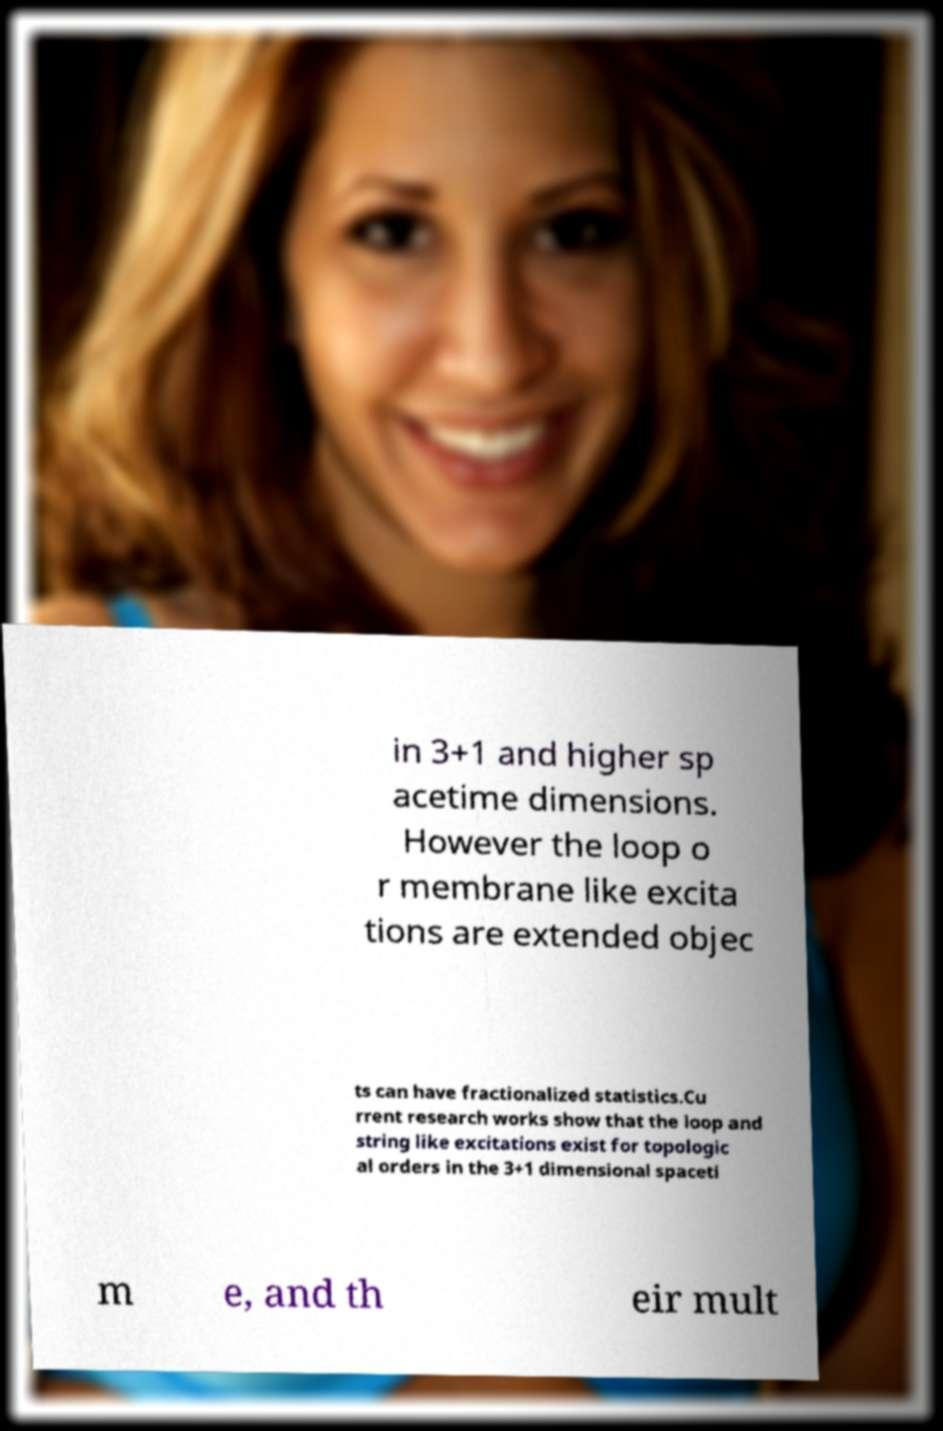Could you extract and type out the text from this image? in 3+1 and higher sp acetime dimensions. However the loop o r membrane like excita tions are extended objec ts can have fractionalized statistics.Cu rrent research works show that the loop and string like excitations exist for topologic al orders in the 3+1 dimensional spaceti m e, and th eir mult 